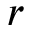Convert formula to latex. <formula><loc_0><loc_0><loc_500><loc_500>r</formula> 